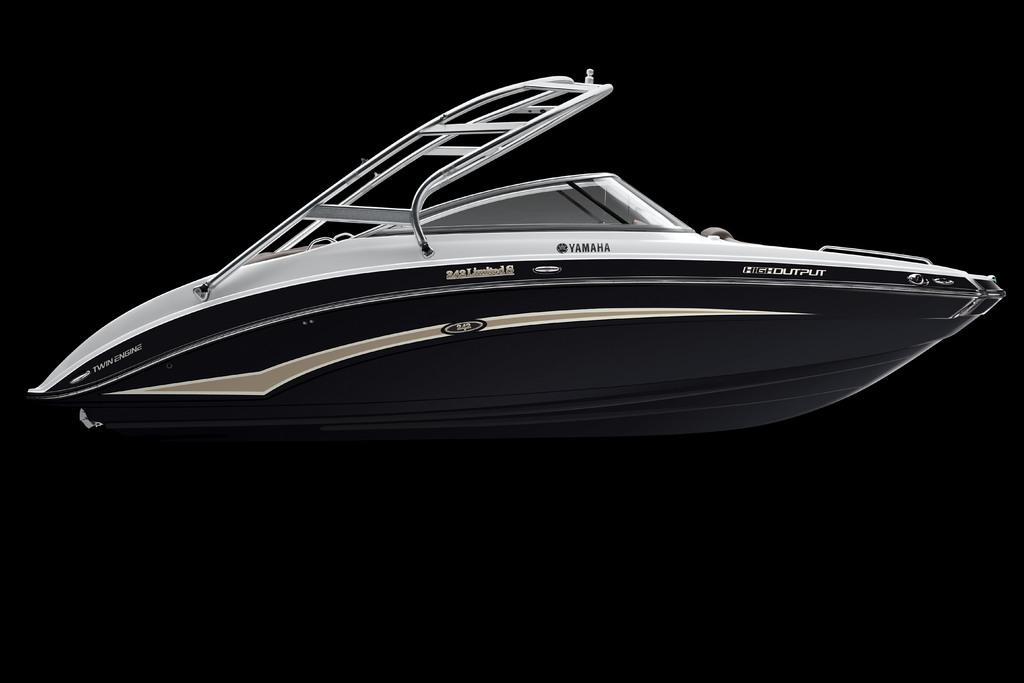<image>
Render a clear and concise summary of the photo. A picture of a Yamaha speedboat on a field of black. 